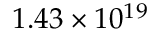Convert formula to latex. <formula><loc_0><loc_0><loc_500><loc_500>1 . 4 3 \times 1 0 ^ { 1 9 }</formula> 